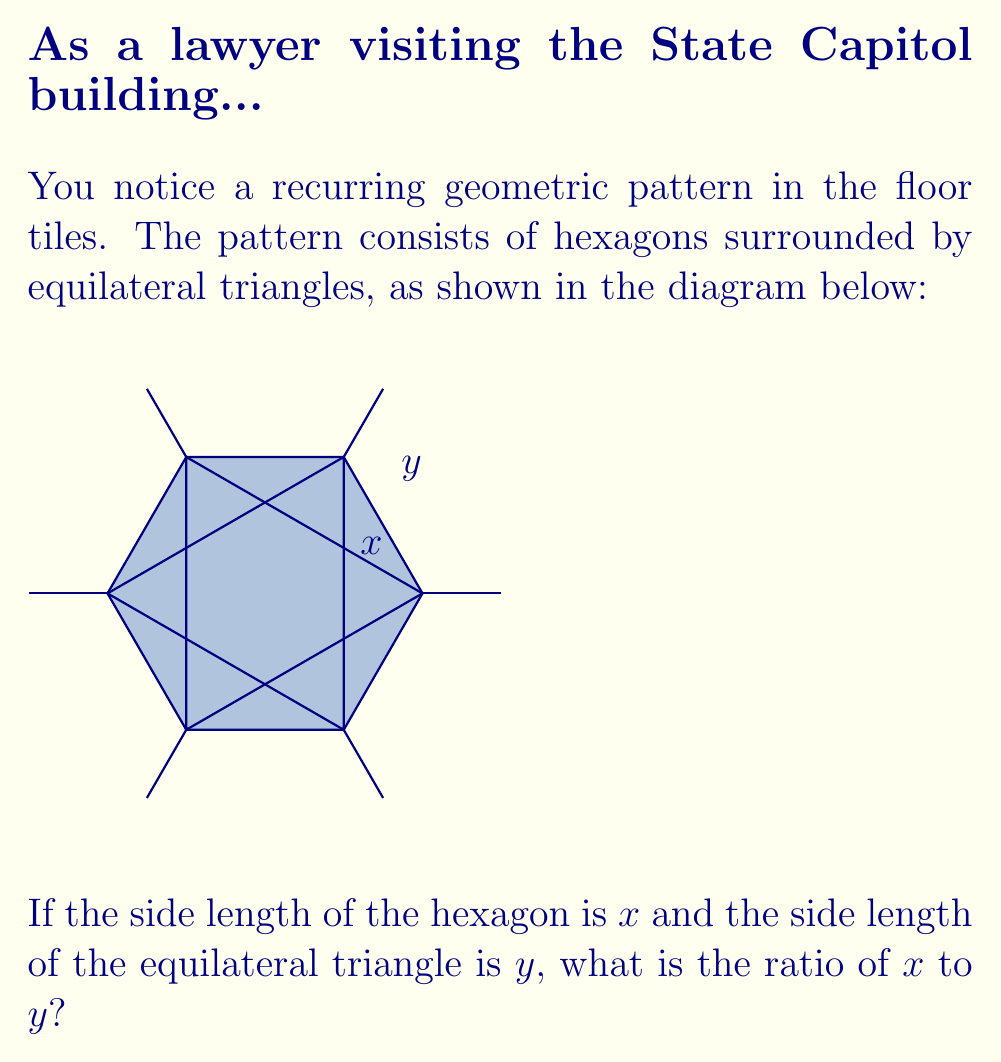Help me with this question. Let's approach this step-by-step:

1) First, we need to recognize that the line segment from the center of the hexagon to any vertex is equal to the side length of the hexagon, $x$.

2) The line segment from the center of the hexagon to the midpoint of any side is perpendicular to that side and forms a 30-60-90 triangle with half of the hexagon's side.

3) In a 30-60-90 triangle, if the shortest side (opposite to the 30° angle) is $\frac{x}{2}$, then the longest side (opposite to the 90° angle) is $\frac{x\sqrt{3}}{2}$.

4) This $\frac{x\sqrt{3}}{2}$ is the height of the equilateral triangle with side length $y$.

5) In an equilateral triangle, the height $h$ relates to the side length $s$ by the formula:

   $$h = \frac{s\sqrt{3}}{2}$$

6) Substituting our values:

   $$\frac{x\sqrt{3}}{2} = \frac{y\sqrt{3}}{2}$$

7) Simplifying:

   $$x = y$$

Therefore, the ratio of $x$ to $y$ is 1:1.
Answer: 1:1 